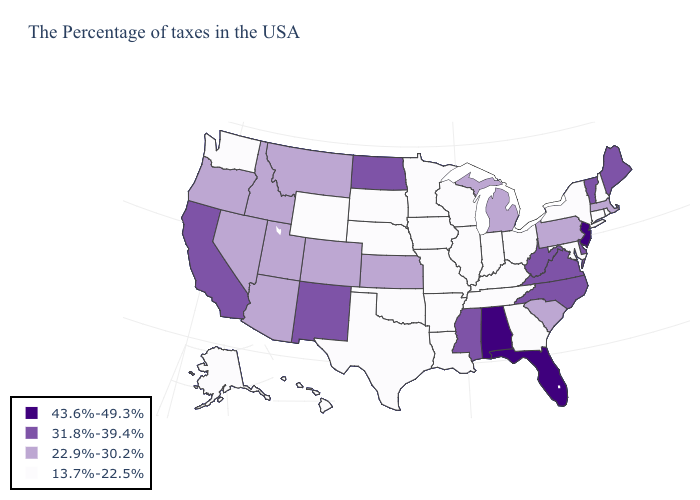What is the value of Iowa?
Give a very brief answer. 13.7%-22.5%. What is the value of Minnesota?
Write a very short answer. 13.7%-22.5%. What is the lowest value in the MidWest?
Quick response, please. 13.7%-22.5%. Name the states that have a value in the range 13.7%-22.5%?
Give a very brief answer. Rhode Island, New Hampshire, Connecticut, New York, Maryland, Ohio, Georgia, Kentucky, Indiana, Tennessee, Wisconsin, Illinois, Louisiana, Missouri, Arkansas, Minnesota, Iowa, Nebraska, Oklahoma, Texas, South Dakota, Wyoming, Washington, Alaska, Hawaii. Does Vermont have the highest value in the Northeast?
Short answer required. No. Among the states that border California , which have the lowest value?
Be succinct. Arizona, Nevada, Oregon. What is the lowest value in the USA?
Write a very short answer. 13.7%-22.5%. Does South Carolina have a lower value than Maine?
Write a very short answer. Yes. What is the lowest value in the MidWest?
Short answer required. 13.7%-22.5%. Does Wyoming have a lower value than Maine?
Write a very short answer. Yes. What is the lowest value in states that border Arkansas?
Concise answer only. 13.7%-22.5%. Name the states that have a value in the range 31.8%-39.4%?
Be succinct. Maine, Vermont, Delaware, Virginia, North Carolina, West Virginia, Mississippi, North Dakota, New Mexico, California. Does Idaho have the lowest value in the USA?
Short answer required. No. Name the states that have a value in the range 31.8%-39.4%?
Keep it brief. Maine, Vermont, Delaware, Virginia, North Carolina, West Virginia, Mississippi, North Dakota, New Mexico, California. Name the states that have a value in the range 31.8%-39.4%?
Write a very short answer. Maine, Vermont, Delaware, Virginia, North Carolina, West Virginia, Mississippi, North Dakota, New Mexico, California. 